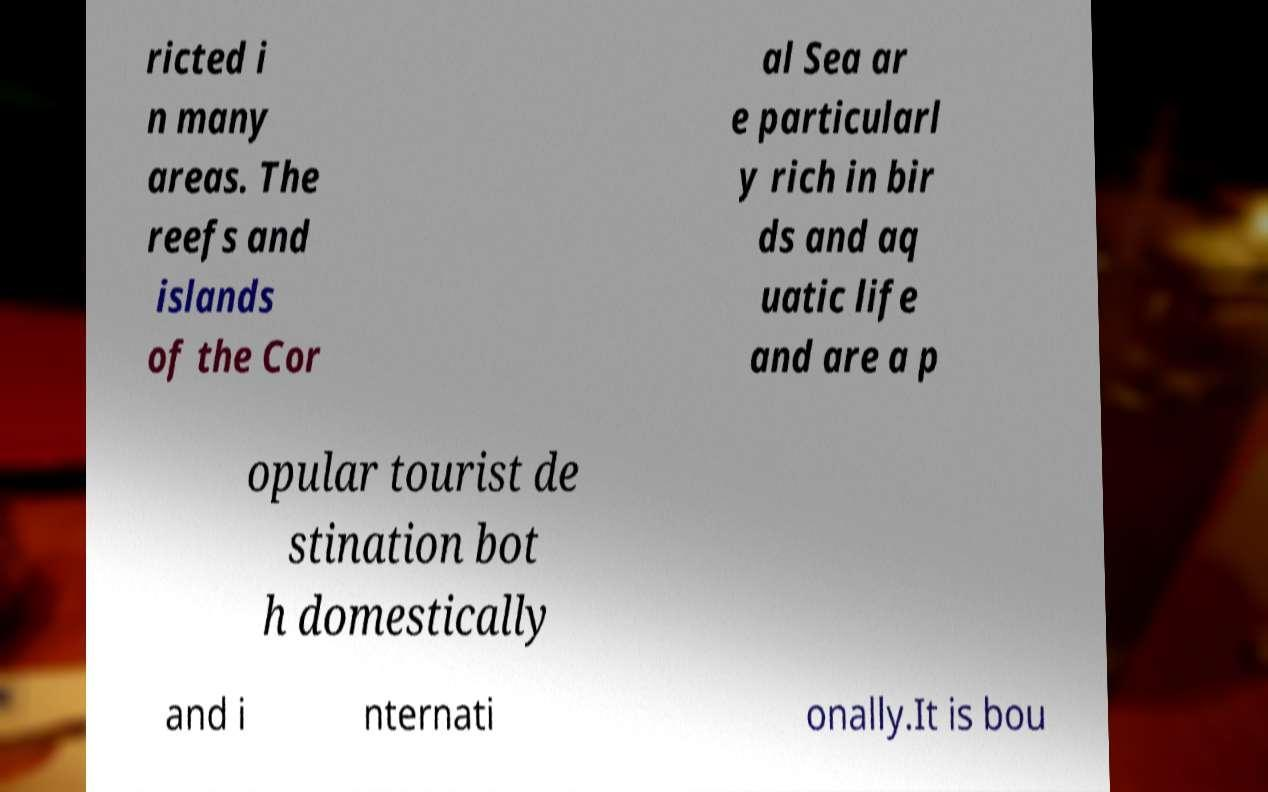Can you read and provide the text displayed in the image?This photo seems to have some interesting text. Can you extract and type it out for me? ricted i n many areas. The reefs and islands of the Cor al Sea ar e particularl y rich in bir ds and aq uatic life and are a p opular tourist de stination bot h domestically and i nternati onally.It is bou 